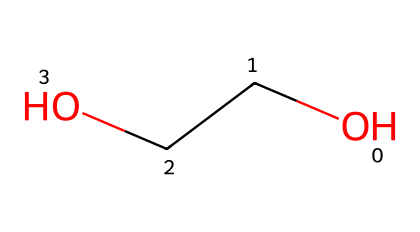What is the IUPAC name of this molecule? The molecule represented by the SMILES "OCCO" contains two carbon atoms and two hydroxyl (OH) groups attached, which corresponds to ethylene glycol. The IUPAC name is derived from its structure where the two carbon atoms are connected by a single bond and each carbon is attached to a hydroxyl group.
Answer: ethylene glycol How many carbon atoms are in the structure? By examining the SMILES representation "OCCO," we can identify the two 'C' characters, which indicate the presence of two carbon atoms in the molecule.
Answer: 2 How many oxygen atoms are present in this chemical? In the SMILES notation "OCCO," there are two 'O' characters representing two oxygen atoms associated with the two hydroxyl groups in the ethylene glycol structure.
Answer: 2 What type of bonding is present between the carbon atoms? The structure indicates a single bond between the two carbon atoms. In the SMILES "OCCO," the absence of any notation for double or triple bonds indicates that the bonds are all single.
Answer: single bond What functional groups are present in this compound? The molecule contains hydroxyl groups (–OH), which contribute properties like high solubility in water. The presence of two –OH groups distinguishes it as a diol, given its connection to carbon atoms, as indicated by the structure "OCCO."
Answer: hydroxyl groups What physical state is ethylene glycol typically found in? Ethylene glycol at room temperature is a liquid due to its relatively low melting point compared to solid-state materials. Its structure allows for fluidity and low viscosity.
Answer: liquid 